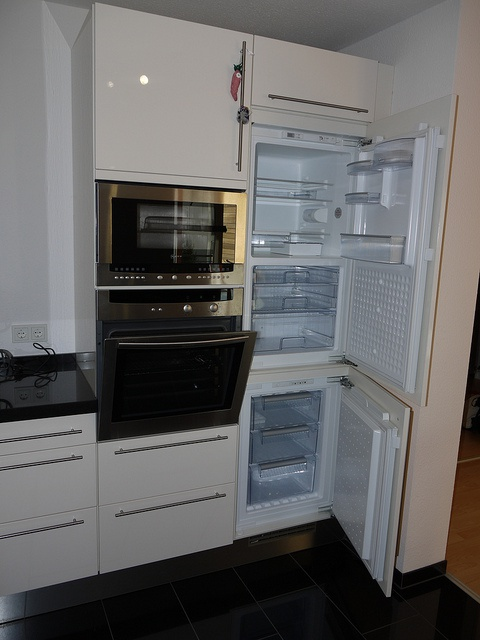Describe the objects in this image and their specific colors. I can see refrigerator in gray tones, oven in gray, black, and darkgray tones, and microwave in gray, black, and olive tones in this image. 